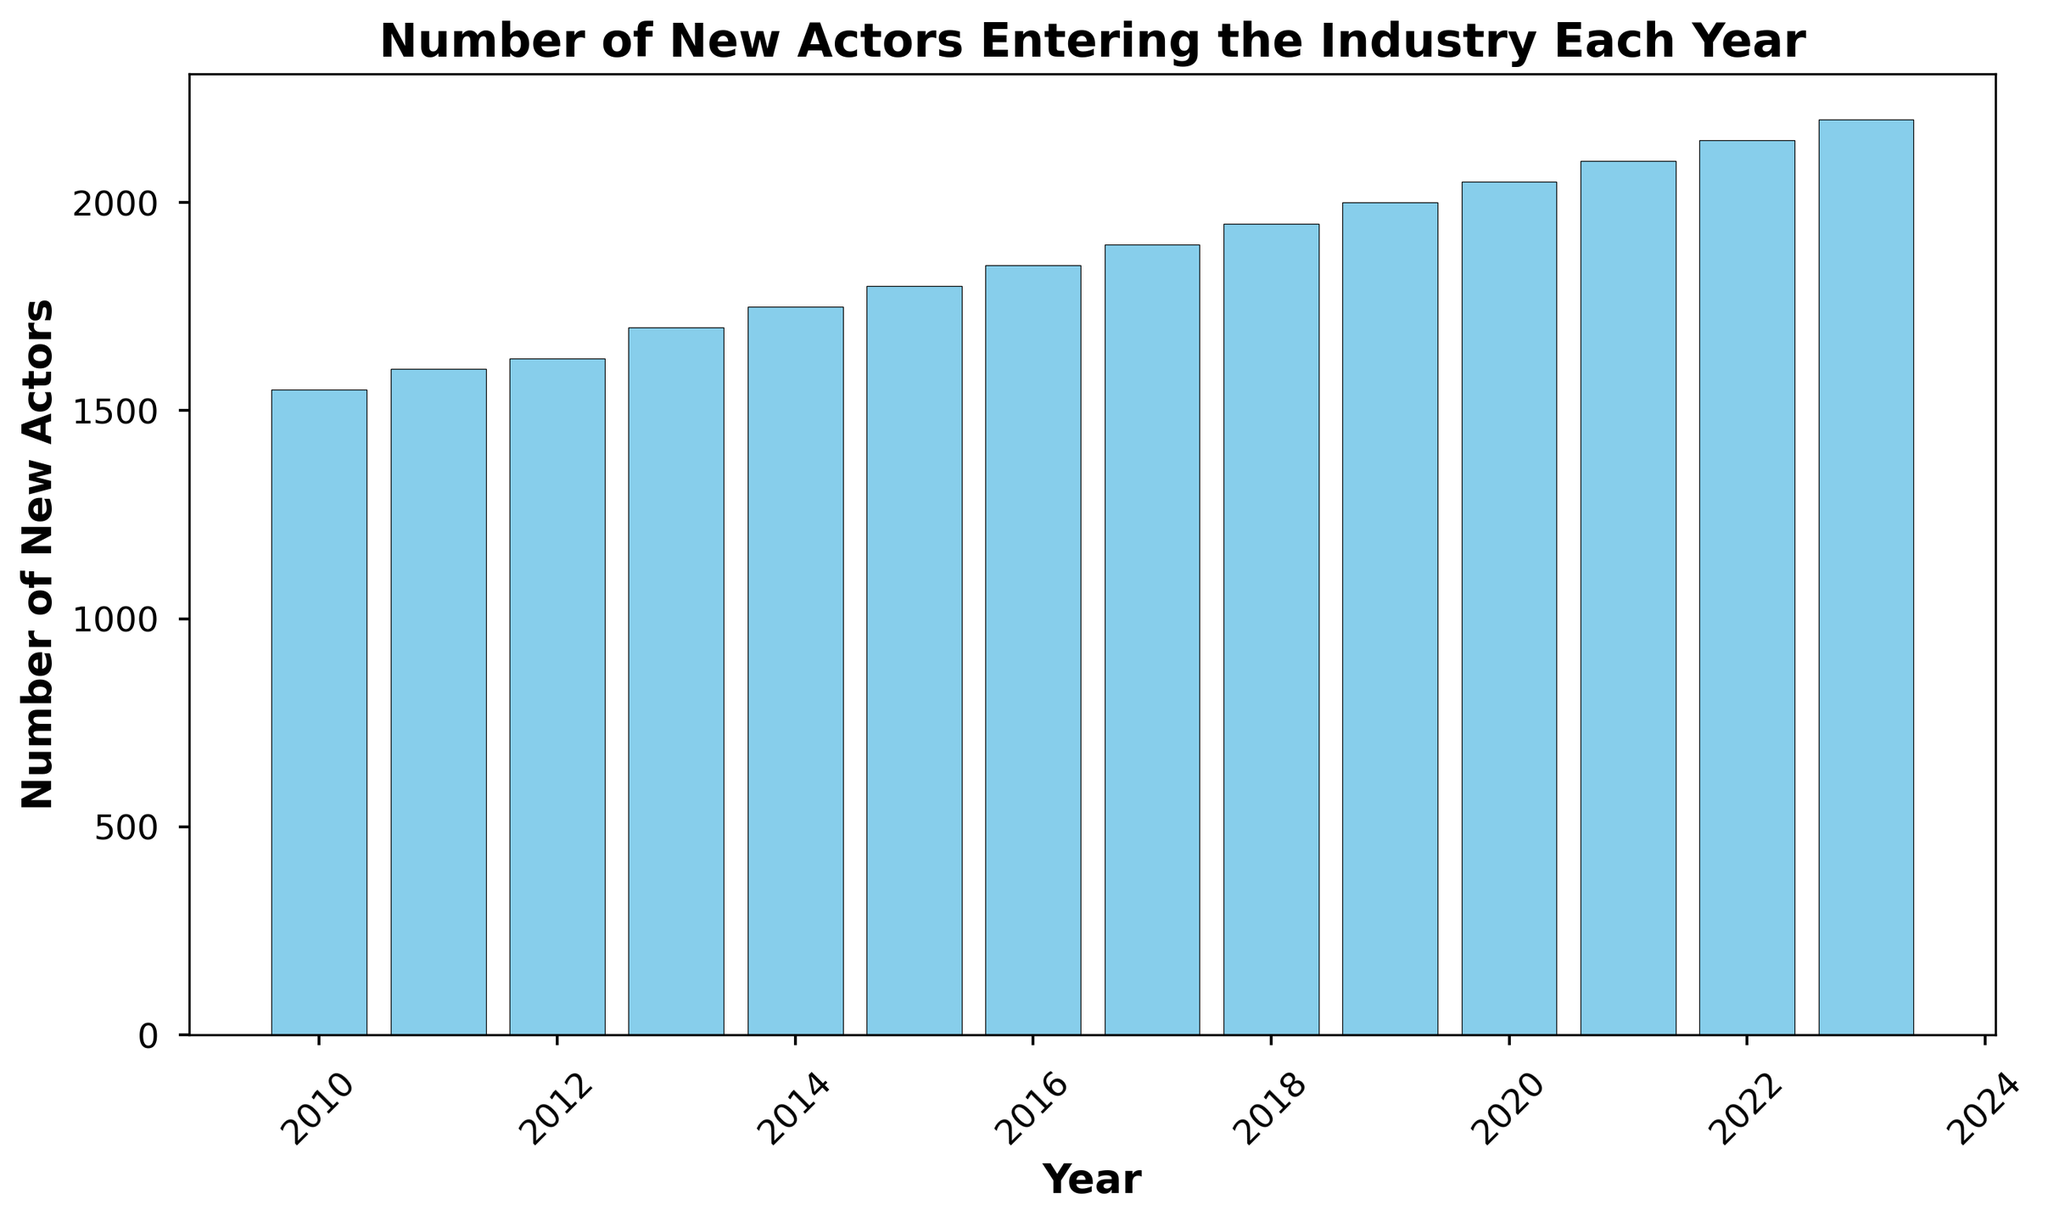Which year had the highest number of new actors entering the industry? To determine the year with the highest number of new actors, look for the tallest bar in the histogram. The tallest bar corresponds to the year 2023 with 2200 new actors.
Answer: 2023 Which year had the lowest number of new actors entering the industry? To determine the year with the lowest number of new actors, look for the shortest bar in the histogram. The shortest bar corresponds to the year 2010 with 1550 new actors.
Answer: 2010 What is the difference in the number of new actors between 2010 and 2023? To find the difference, subtract the number of new actors in 2010 from the number of new actors in 2023. The calculation is 2200 - 1550 = 650.
Answer: 650 What is the average number of new actors entering the industry per year from 2010 to 2023? To find the average, sum up the number of new actors for each year and then divide by the total number of years (14). The total sum is 26025 (1550 + 1600 + 1625 + 1700 + 1750 + 1800 + 1850 + 1900 + 1950 + 2000 + 2050 + 2100 + 2150 + 2200), so the average is 26025 / 14 ≈ 1858.
Answer: 1858 Was there a consistent increase in the number of new actors each year? To see if there was a consistent increase, observe the general trend of the bars in the histogram. Each subsequent year from 2010 to 2023 shows an increase in the number of new actors, indicating a consistent upward trend.
Answer: Yes How many years had more than 1900 new actors entering the industry? Count the number of bars that represent years with more than 1900 new actors. These bars correspond to the years 2018, 2019, 2020, 2021, 2022, and 2023. There are 6 such years.
Answer: 6 In which years did the number of new actors exceed 2000? Identify the bars that exceed the 2000 mark. These bars correspond to the years 2020, 2021, 2022, and 2023. There are four such years.
Answer: 2020, 2021, 2022, 2023 Which year saw the largest increase in the number of new actors compared to the previous year? To find the largest increase, compare the differences in the number of new actors between successive years and see which is the largest. The largest increase is from 2012 (1625) to 2013 (1700), which is a difference of 75.
Answer: 2012 to 2013 